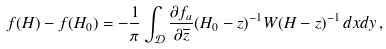<formula> <loc_0><loc_0><loc_500><loc_500>f ( H ) - f ( H _ { 0 } ) = - \frac { 1 } { \pi } \int _ { \mathcal { D } } \frac { \partial f _ { a } } { \partial \overline { z } } ( H _ { 0 } - z ) ^ { - 1 } W ( H - z ) ^ { - 1 } \, d x d y \, ,</formula> 